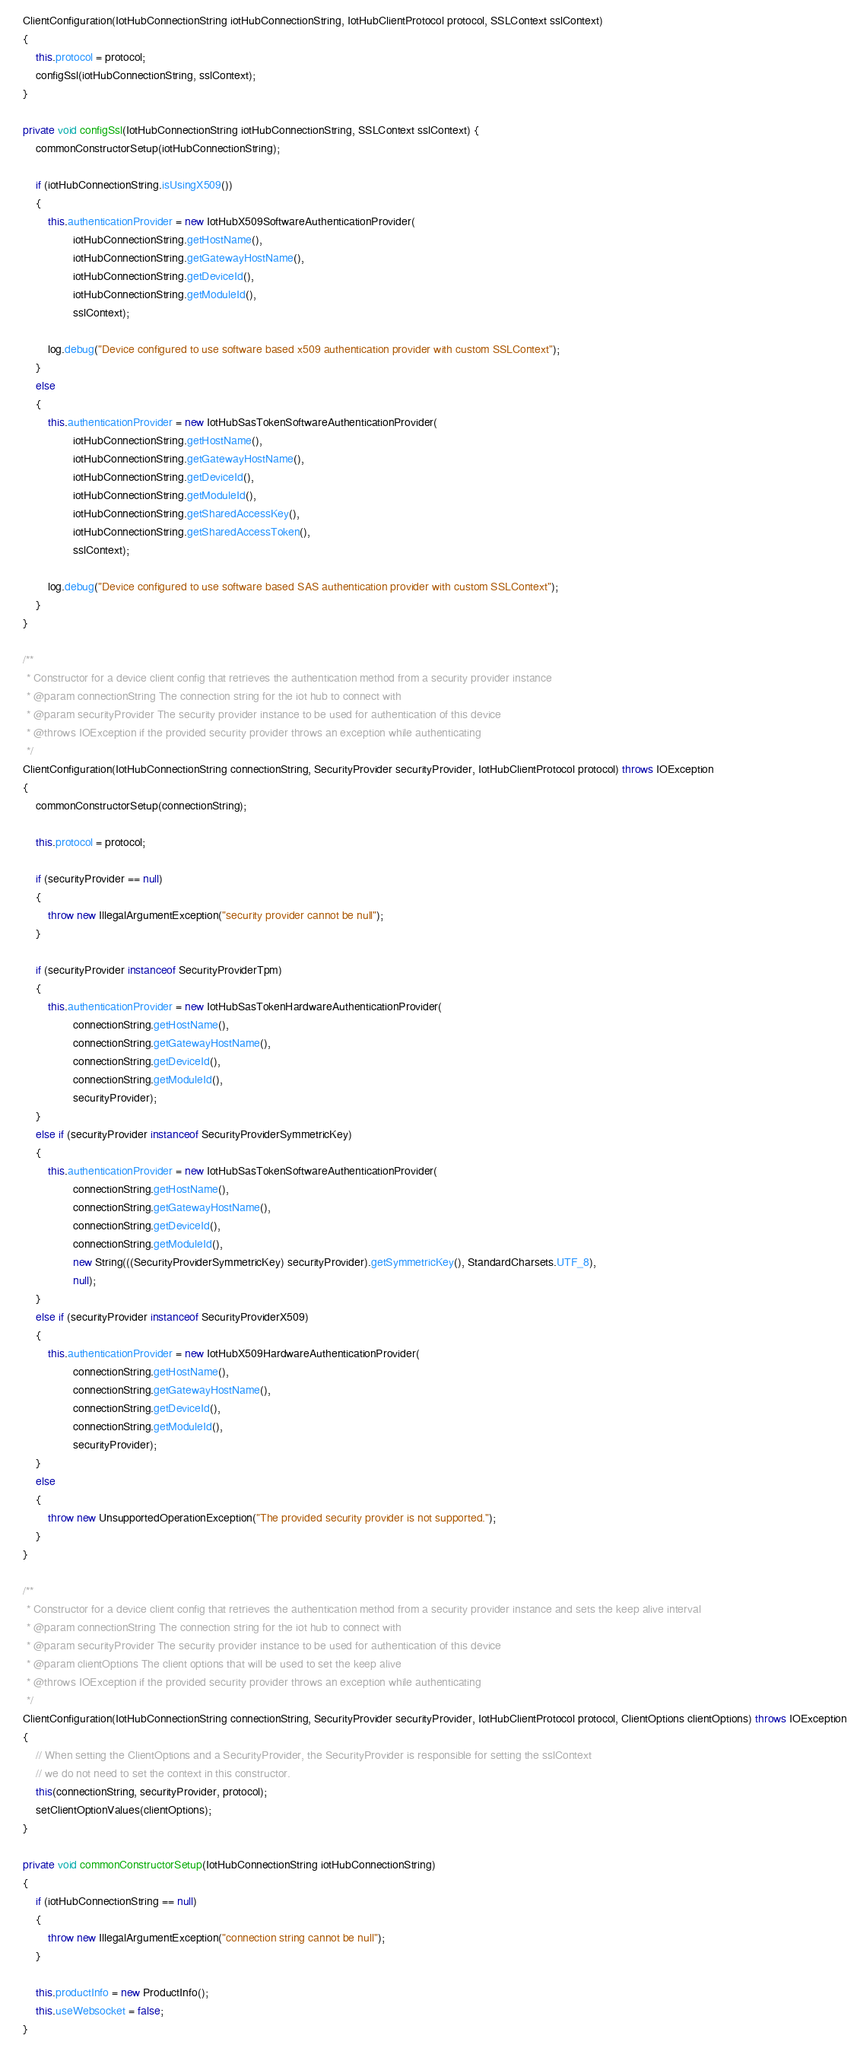Convert code to text. <code><loc_0><loc_0><loc_500><loc_500><_Java_>
    ClientConfiguration(IotHubConnectionString iotHubConnectionString, IotHubClientProtocol protocol, SSLContext sslContext)
    {
        this.protocol = protocol;
        configSsl(iotHubConnectionString, sslContext);
    }

    private void configSsl(IotHubConnectionString iotHubConnectionString, SSLContext sslContext) {
        commonConstructorSetup(iotHubConnectionString);

        if (iotHubConnectionString.isUsingX509())
        {
            this.authenticationProvider = new IotHubX509SoftwareAuthenticationProvider(
                    iotHubConnectionString.getHostName(),
                    iotHubConnectionString.getGatewayHostName(),
                    iotHubConnectionString.getDeviceId(),
                    iotHubConnectionString.getModuleId(),
                    sslContext);

            log.debug("Device configured to use software based x509 authentication provider with custom SSLContext");
        }
        else
        {
            this.authenticationProvider = new IotHubSasTokenSoftwareAuthenticationProvider(
                    iotHubConnectionString.getHostName(),
                    iotHubConnectionString.getGatewayHostName(),
                    iotHubConnectionString.getDeviceId(),
                    iotHubConnectionString.getModuleId(),
                    iotHubConnectionString.getSharedAccessKey(),
                    iotHubConnectionString.getSharedAccessToken(),
                    sslContext);

            log.debug("Device configured to use software based SAS authentication provider with custom SSLContext");
        }
    }

    /**
     * Constructor for a device client config that retrieves the authentication method from a security provider instance
     * @param connectionString The connection string for the iot hub to connect with
     * @param securityProvider The security provider instance to be used for authentication of this device
     * @throws IOException if the provided security provider throws an exception while authenticating
     */
    ClientConfiguration(IotHubConnectionString connectionString, SecurityProvider securityProvider, IotHubClientProtocol protocol) throws IOException
    {
        commonConstructorSetup(connectionString);

        this.protocol = protocol;

        if (securityProvider == null)
        {
            throw new IllegalArgumentException("security provider cannot be null");
        }

        if (securityProvider instanceof SecurityProviderTpm)
        {
            this.authenticationProvider = new IotHubSasTokenHardwareAuthenticationProvider(
                    connectionString.getHostName(),
                    connectionString.getGatewayHostName(),
                    connectionString.getDeviceId(),
                    connectionString.getModuleId(),
                    securityProvider);
        }
        else if (securityProvider instanceof SecurityProviderSymmetricKey)
        {
            this.authenticationProvider = new IotHubSasTokenSoftwareAuthenticationProvider(
                    connectionString.getHostName(),
                    connectionString.getGatewayHostName(),
                    connectionString.getDeviceId(),
                    connectionString.getModuleId(),
                    new String(((SecurityProviderSymmetricKey) securityProvider).getSymmetricKey(), StandardCharsets.UTF_8),
                    null);
        }
        else if (securityProvider instanceof SecurityProviderX509)
        {
            this.authenticationProvider = new IotHubX509HardwareAuthenticationProvider(
                    connectionString.getHostName(),
                    connectionString.getGatewayHostName(),
                    connectionString.getDeviceId(),
                    connectionString.getModuleId(),
                    securityProvider);
        }
        else
        {
            throw new UnsupportedOperationException("The provided security provider is not supported.");
        }
    }

    /**
     * Constructor for a device client config that retrieves the authentication method from a security provider instance and sets the keep alive interval
     * @param connectionString The connection string for the iot hub to connect with
     * @param securityProvider The security provider instance to be used for authentication of this device
     * @param clientOptions The client options that will be used to set the keep alive
     * @throws IOException if the provided security provider throws an exception while authenticating
     */
    ClientConfiguration(IotHubConnectionString connectionString, SecurityProvider securityProvider, IotHubClientProtocol protocol, ClientOptions clientOptions) throws IOException
    {
        // When setting the ClientOptions and a SecurityProvider, the SecurityProvider is responsible for setting the sslContext
        // we do not need to set the context in this constructor.
        this(connectionString, securityProvider, protocol);
        setClientOptionValues(clientOptions);
    }

    private void commonConstructorSetup(IotHubConnectionString iotHubConnectionString)
    {
        if (iotHubConnectionString == null)
        {
            throw new IllegalArgumentException("connection string cannot be null");
        }

        this.productInfo = new ProductInfo();
        this.useWebsocket = false;
    }
</code> 